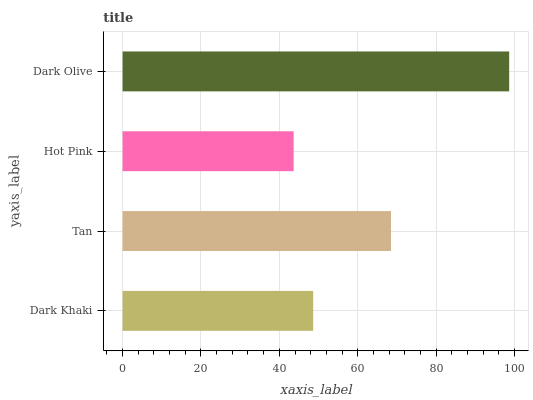Is Hot Pink the minimum?
Answer yes or no. Yes. Is Dark Olive the maximum?
Answer yes or no. Yes. Is Tan the minimum?
Answer yes or no. No. Is Tan the maximum?
Answer yes or no. No. Is Tan greater than Dark Khaki?
Answer yes or no. Yes. Is Dark Khaki less than Tan?
Answer yes or no. Yes. Is Dark Khaki greater than Tan?
Answer yes or no. No. Is Tan less than Dark Khaki?
Answer yes or no. No. Is Tan the high median?
Answer yes or no. Yes. Is Dark Khaki the low median?
Answer yes or no. Yes. Is Dark Khaki the high median?
Answer yes or no. No. Is Dark Olive the low median?
Answer yes or no. No. 